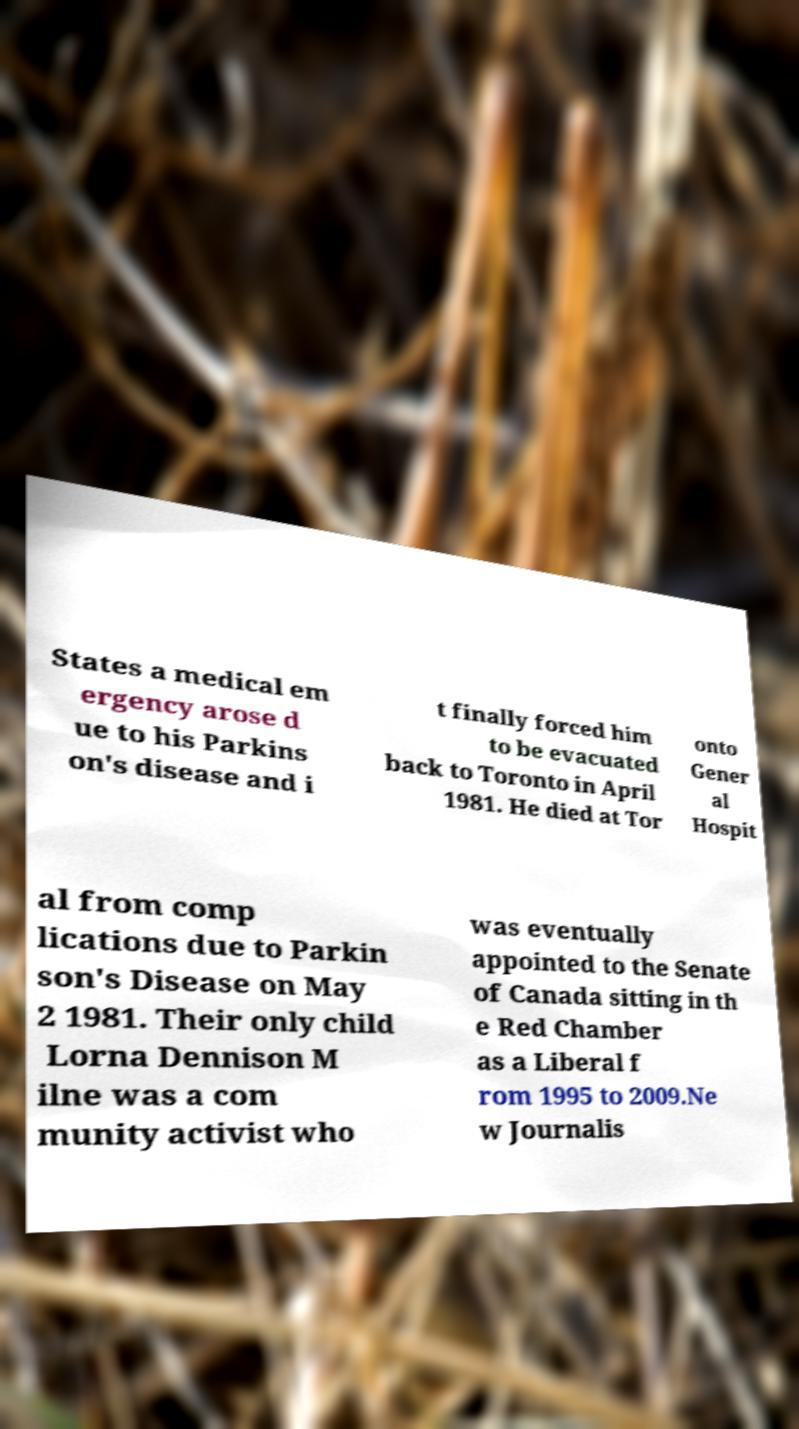I need the written content from this picture converted into text. Can you do that? States a medical em ergency arose d ue to his Parkins on's disease and i t finally forced him to be evacuated back to Toronto in April 1981. He died at Tor onto Gener al Hospit al from comp lications due to Parkin son's Disease on May 2 1981. Their only child Lorna Dennison M ilne was a com munity activist who was eventually appointed to the Senate of Canada sitting in th e Red Chamber as a Liberal f rom 1995 to 2009.Ne w Journalis 